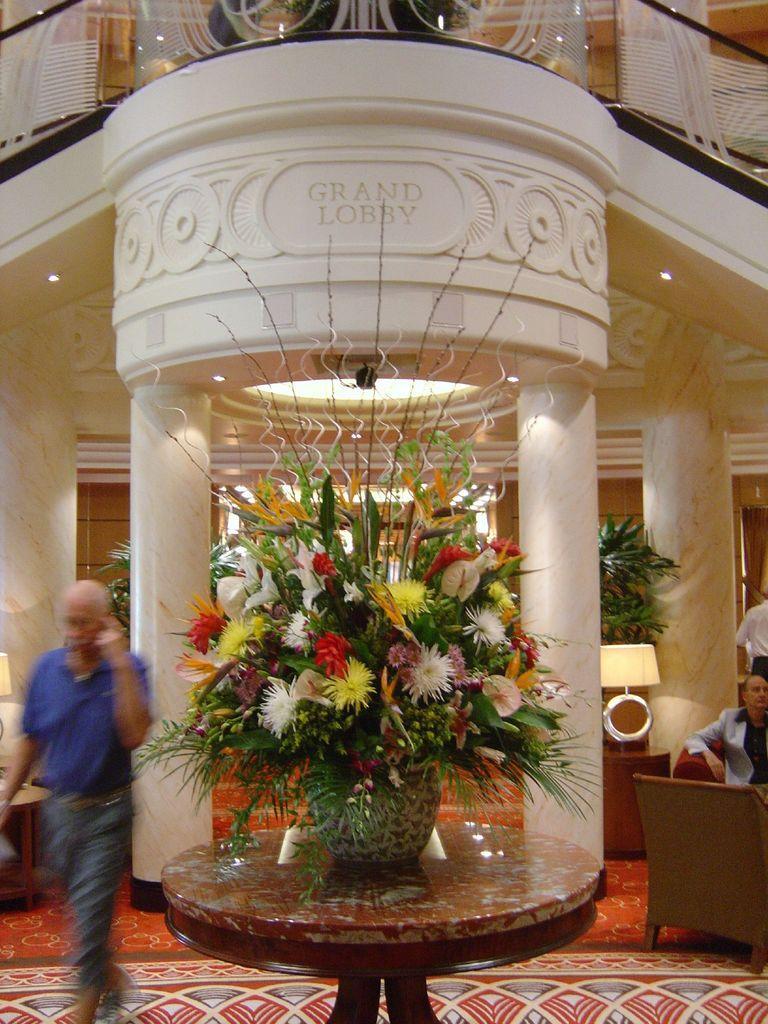Could you give a brief overview of what you see in this image? In this picture I can see the inside view of a building, there is a flower vase on the table, there is a chair, there are lamps, house plants, lights and there are few people. 